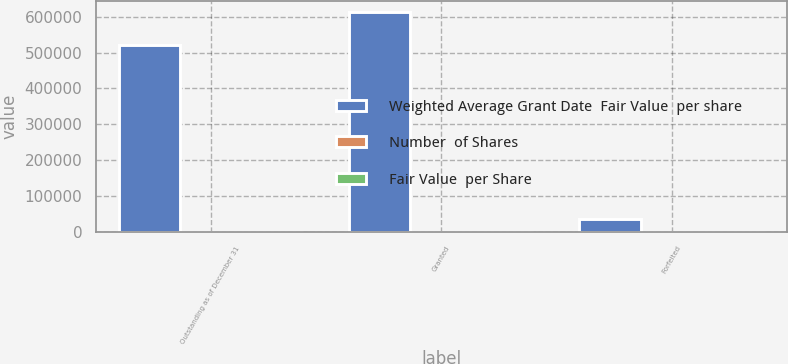<chart> <loc_0><loc_0><loc_500><loc_500><stacked_bar_chart><ecel><fcel>Outstanding as of December 31<fcel>Granted<fcel>Forfeited<nl><fcel>Weighted Average Grant Date  Fair Value  per share<fcel>520762<fcel>613570<fcel>35249<nl><fcel>Number  of Shares<fcel>23.56<fcel>32.98<fcel>24.3<nl><fcel>Fair Value  per Share<fcel>21.53<fcel>27.46<fcel>22<nl></chart> 